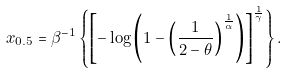Convert formula to latex. <formula><loc_0><loc_0><loc_500><loc_500>x _ { 0 . 5 } = \beta ^ { - 1 } \left \{ \left [ - \log \left ( 1 - \left ( \frac { 1 } { 2 - \theta } \right ) ^ { \frac { 1 } { \alpha } } \right ) \right ] ^ { \frac { 1 } { \gamma } } \right \} .</formula> 